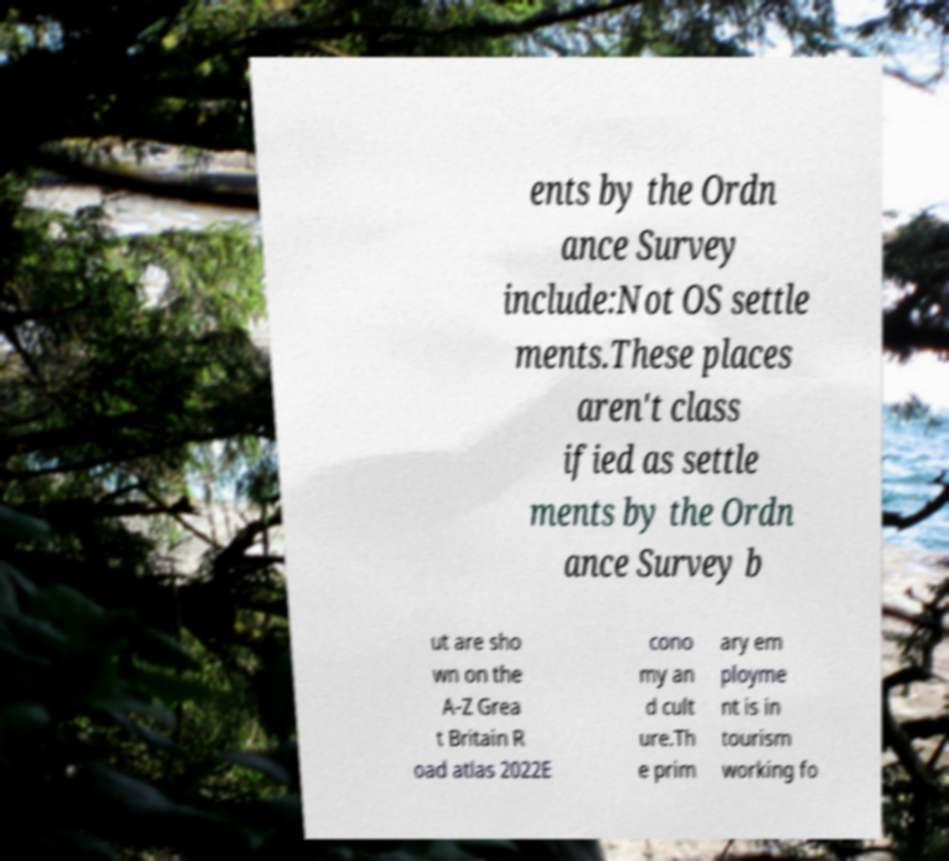Can you read and provide the text displayed in the image?This photo seems to have some interesting text. Can you extract and type it out for me? ents by the Ordn ance Survey include:Not OS settle ments.These places aren't class ified as settle ments by the Ordn ance Survey b ut are sho wn on the A-Z Grea t Britain R oad atlas 2022E cono my an d cult ure.Th e prim ary em ployme nt is in tourism working fo 